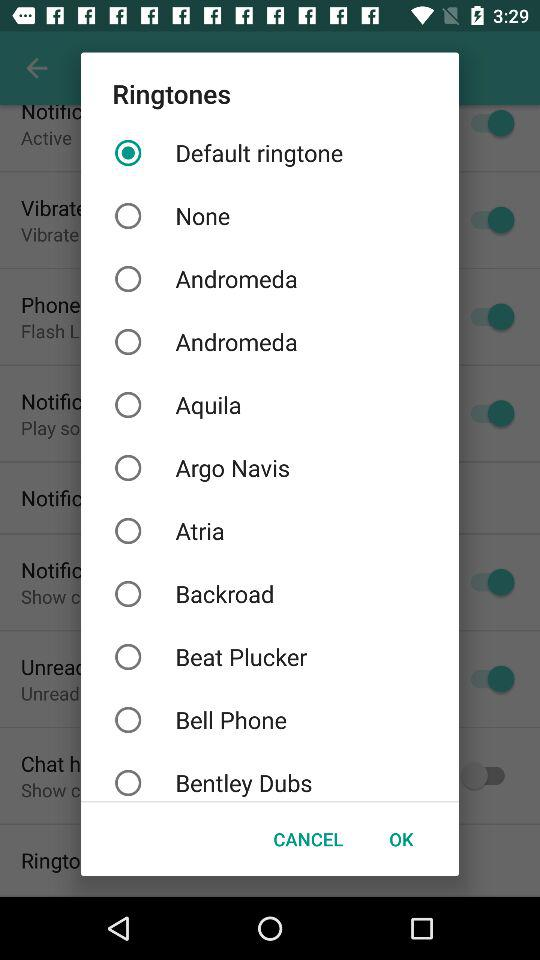Which option was selected? The selected option was "Default ringtone". 